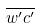<formula> <loc_0><loc_0><loc_500><loc_500>\overline { w ^ { \prime } c ^ { \prime } }</formula> 